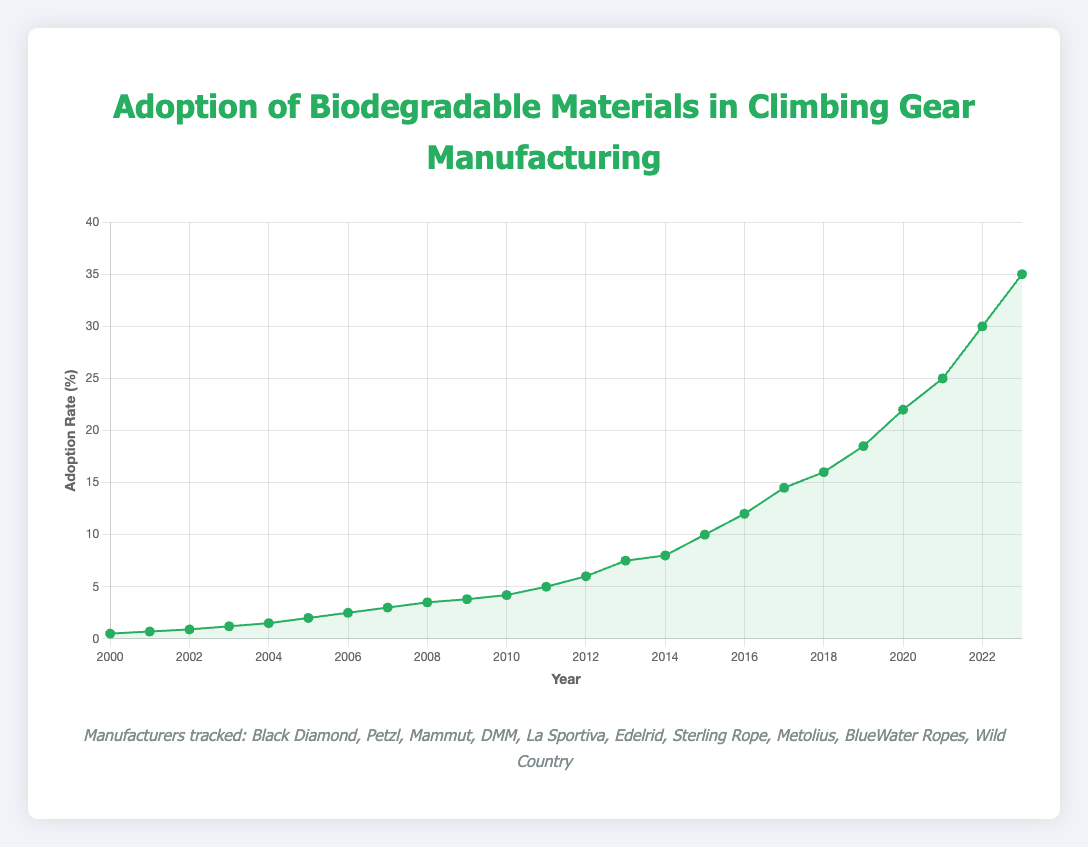What is the adoption rate of biodegradable materials in climbing gear manufacturing in 2010? The chart shows the adoption rate for each year. For 2010, it is indicated at the mark corresponding to that year.
Answer: 4.2% How many years did it take for the adoption rate to reach 10% from 0.5%? Identify the years when the adoption rates are 0.5% and 10%, then calculate the difference between those years. 0.5% was in 2000 and 10% in 2015, so it took 15 years.
Answer: 15 years Between 2015 and 2020, by how much did the adoption rate increase? Find the adoption rates for 2015 and 2020, then subtract the former from the latter. For 2015, the rate is 10%, and for 2020, the rate is 22%. 22% - 10% = 12%.
Answer: 12% Which year had the steepest increase in adoption rate compared to the previous year? Compare the differences in adoption rates year-over-year and identify the largest increase. Between 2013 (7.5%) and 2014 (8.0%) is 0.5%, whereas between 2021 (25%) and 2022 (30%) is 5%. 2021 to 2022 is the largest increase of 5%.
Answer: 2022 Is the adoption rate in 2007 greater than in 2005? Compare the values from the chart. In 2005, the rate is 2.0%, and in 2007, it is 3.0%. Since 3.0% is greater than 2.0%, the adoption rate in 2007 is greater.
Answer: Yes What was the adoption rate at the midpoint year between 2000 and 2023? The midpoint year between 2000 and 2023 is calculated as (2000 + 2023) / 2 = 2011.5, rounding down to 2011. Look at the chart for 2011.
Answer: 5.0% During which decade did the adoption rate see the greatest increase? Sum the adoption rate increases for each decade and compare. From 2000 to 2010, it increased by 4.2% - 0.5% = 3.7%. From 2010 to 2020, it increased from 4.2% to 22% = 17.8%. 2010 to 2020 shows the greatest increase.
Answer: 2010s What is the average adoption rate from 2000 to 2005? Sum the adoption rates from 2000 (0.5%) to 2005 (2.0%) and divide by the total number of years. (0.5 + 0.7 + 0.9 + 1.2 + 1.5 + 2.0)/6 = 6/6 = 1.3%.
Answer: 1.3% In which year did the adoption rate first exceed 5%? Identify the year where the adoption rate data from the chart first surpasses 5%. In 2012, the rate is 6.0%, making it the first year to exceed 5%.
Answer: 2012 